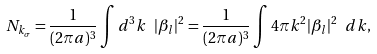<formula> <loc_0><loc_0><loc_500><loc_500>N _ { k _ { \sigma } } = \frac { 1 } { ( 2 \pi a ) ^ { 3 } } \int { d ^ { 3 } k \ | \beta _ { l } | ^ { 2 } } = \frac { 1 } { ( 2 \pi a ) ^ { 3 } } \int { 4 \pi k ^ { 2 } | \beta _ { l } | ^ { 2 } } \ d k ,</formula> 